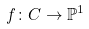<formula> <loc_0><loc_0><loc_500><loc_500>f \colon C \to \mathbb { P } ^ { 1 }</formula> 